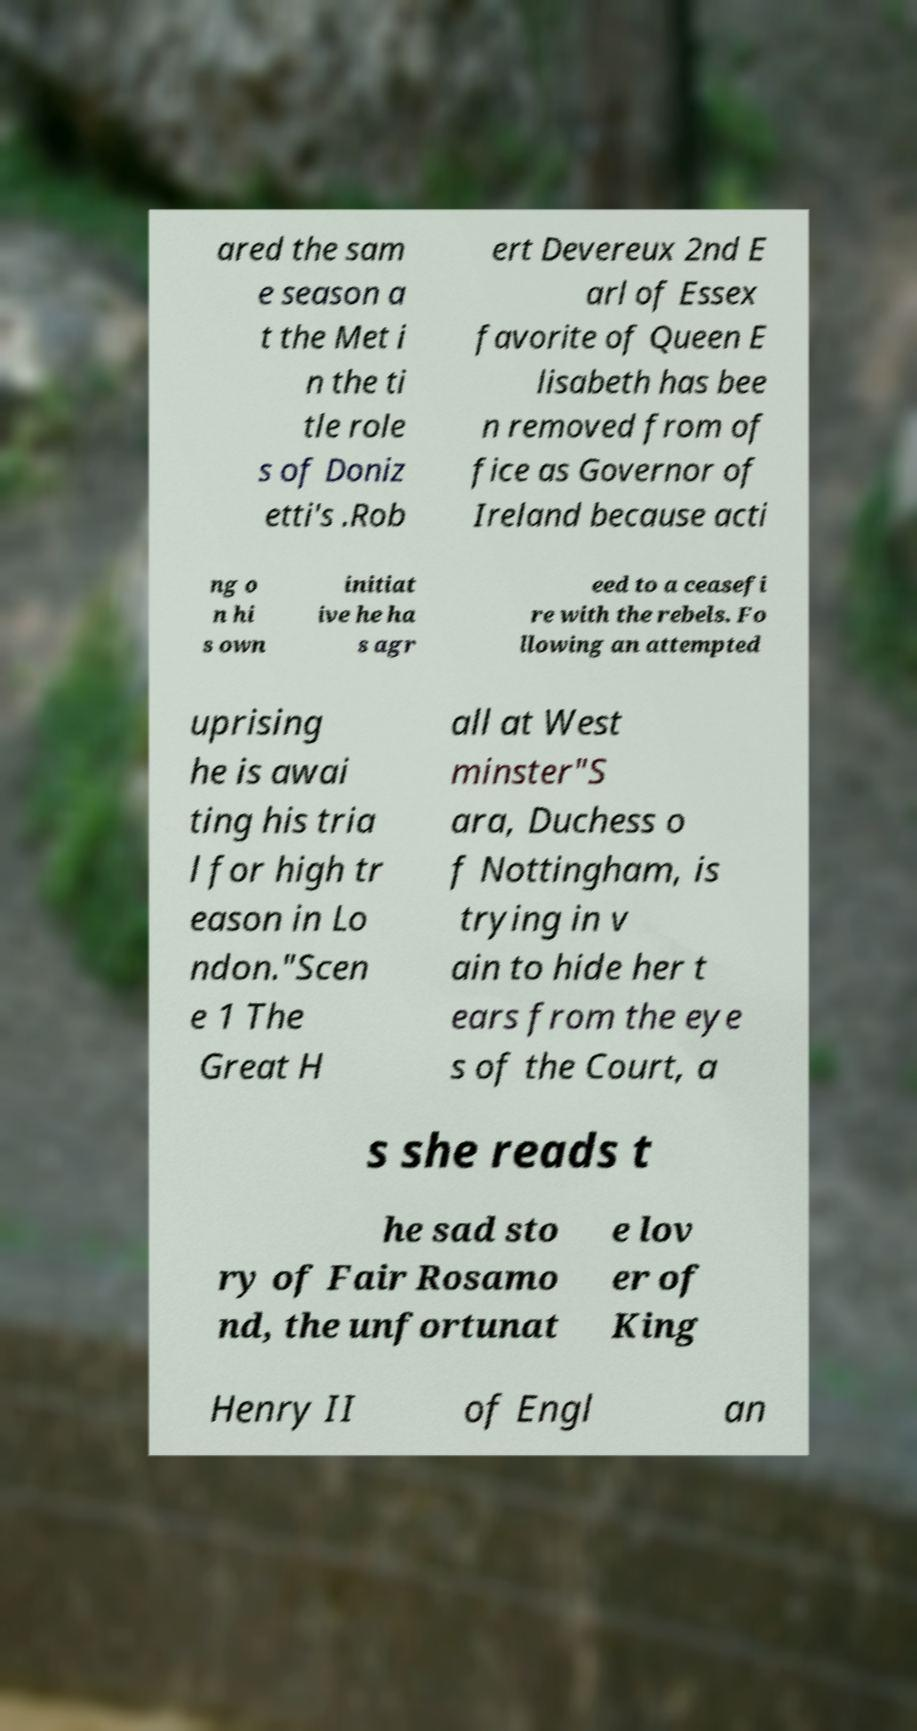Can you accurately transcribe the text from the provided image for me? ared the sam e season a t the Met i n the ti tle role s of Doniz etti's .Rob ert Devereux 2nd E arl of Essex favorite of Queen E lisabeth has bee n removed from of fice as Governor of Ireland because acti ng o n hi s own initiat ive he ha s agr eed to a ceasefi re with the rebels. Fo llowing an attempted uprising he is awai ting his tria l for high tr eason in Lo ndon."Scen e 1 The Great H all at West minster"S ara, Duchess o f Nottingham, is trying in v ain to hide her t ears from the eye s of the Court, a s she reads t he sad sto ry of Fair Rosamo nd, the unfortunat e lov er of King Henry II of Engl an 